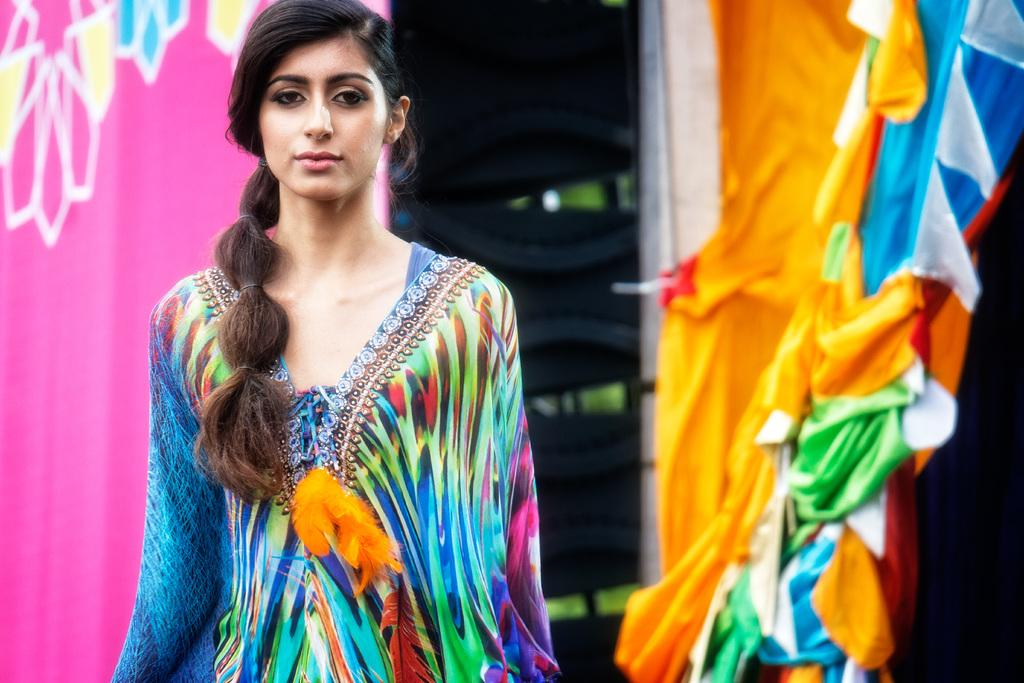Who is present in the image? There is a woman in the image. What is the woman wearing? The woman is wearing a colorful dress. What is the woman doing in the image? The woman is standing. What can be seen on the right side of the image? There are colorful clothes hanging on the right side of the image. What is visible in the background on the left side of the image? There is a pink cloth in the background on the left side of the image. What type of insurance policy is the woman holding in the image? There is no insurance policy present in the image; the woman is wearing a colorful dress and standing. 